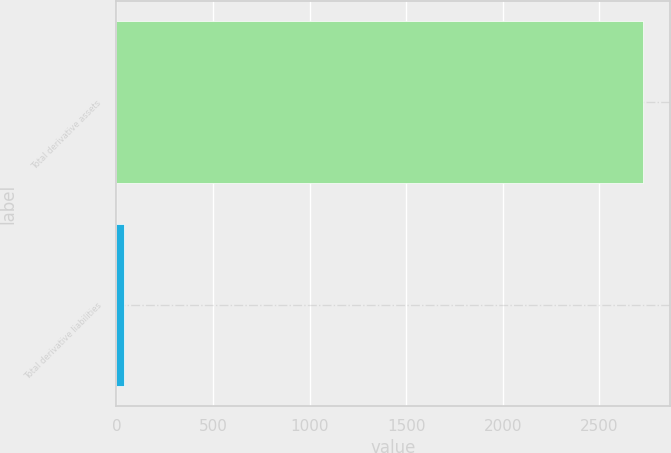Convert chart. <chart><loc_0><loc_0><loc_500><loc_500><bar_chart><fcel>Total derivative assets<fcel>Total derivative liabilities<nl><fcel>2728<fcel>40<nl></chart> 